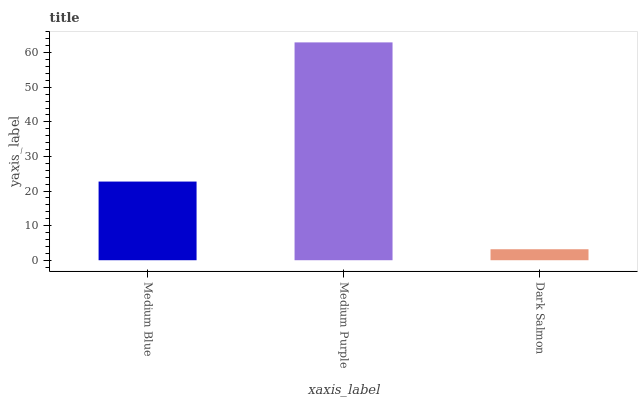Is Dark Salmon the minimum?
Answer yes or no. Yes. Is Medium Purple the maximum?
Answer yes or no. Yes. Is Medium Purple the minimum?
Answer yes or no. No. Is Dark Salmon the maximum?
Answer yes or no. No. Is Medium Purple greater than Dark Salmon?
Answer yes or no. Yes. Is Dark Salmon less than Medium Purple?
Answer yes or no. Yes. Is Dark Salmon greater than Medium Purple?
Answer yes or no. No. Is Medium Purple less than Dark Salmon?
Answer yes or no. No. Is Medium Blue the high median?
Answer yes or no. Yes. Is Medium Blue the low median?
Answer yes or no. Yes. Is Medium Purple the high median?
Answer yes or no. No. Is Medium Purple the low median?
Answer yes or no. No. 